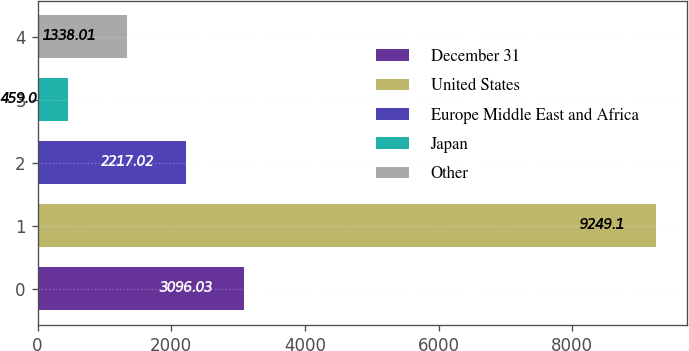<chart> <loc_0><loc_0><loc_500><loc_500><bar_chart><fcel>December 31<fcel>United States<fcel>Europe Middle East and Africa<fcel>Japan<fcel>Other<nl><fcel>3096.03<fcel>9249.1<fcel>2217.02<fcel>459<fcel>1338.01<nl></chart> 